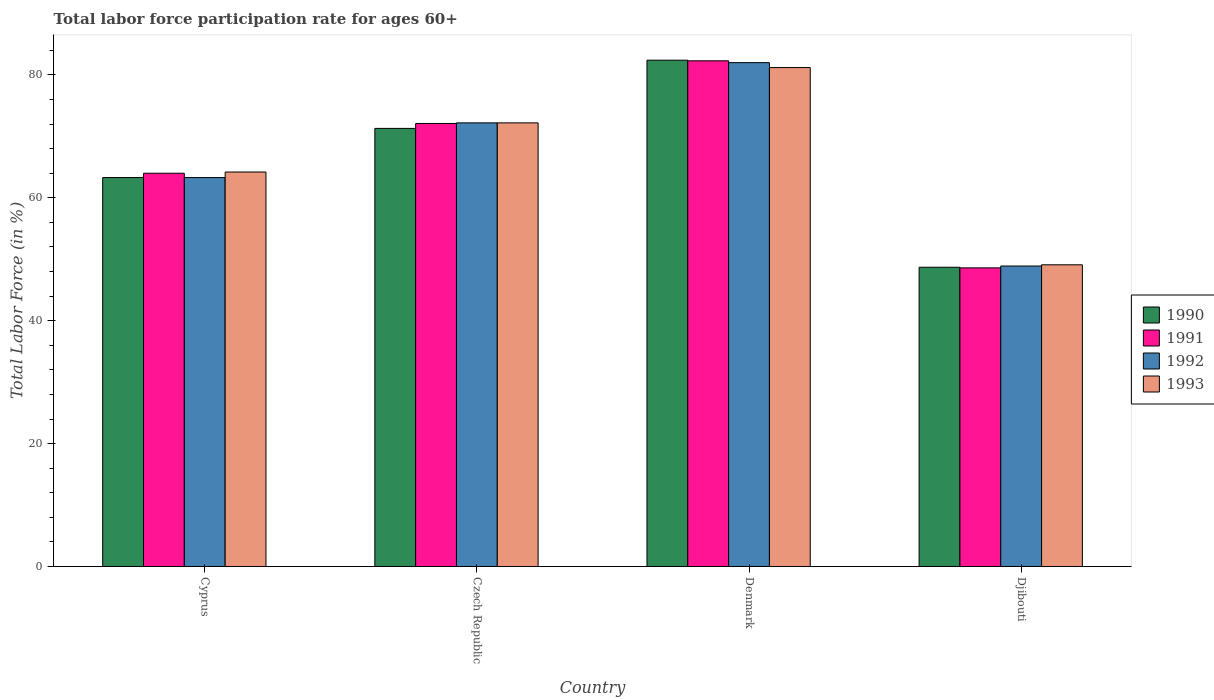How many different coloured bars are there?
Your answer should be very brief. 4. How many groups of bars are there?
Offer a very short reply. 4. How many bars are there on the 1st tick from the left?
Your answer should be very brief. 4. How many bars are there on the 3rd tick from the right?
Make the answer very short. 4. What is the label of the 2nd group of bars from the left?
Offer a very short reply. Czech Republic. In how many cases, is the number of bars for a given country not equal to the number of legend labels?
Make the answer very short. 0. What is the labor force participation rate in 1992 in Djibouti?
Offer a terse response. 48.9. Across all countries, what is the maximum labor force participation rate in 1991?
Your response must be concise. 82.3. Across all countries, what is the minimum labor force participation rate in 1993?
Keep it short and to the point. 49.1. In which country was the labor force participation rate in 1991 minimum?
Offer a terse response. Djibouti. What is the total labor force participation rate in 1992 in the graph?
Provide a short and direct response. 266.4. What is the difference between the labor force participation rate in 1991 in Czech Republic and that in Djibouti?
Offer a terse response. 23.5. What is the difference between the labor force participation rate in 1990 in Djibouti and the labor force participation rate in 1993 in Denmark?
Make the answer very short. -32.5. What is the average labor force participation rate in 1990 per country?
Ensure brevity in your answer.  66.43. What is the difference between the labor force participation rate of/in 1990 and labor force participation rate of/in 1992 in Djibouti?
Make the answer very short. -0.2. In how many countries, is the labor force participation rate in 1993 greater than 12 %?
Your response must be concise. 4. What is the ratio of the labor force participation rate in 1990 in Denmark to that in Djibouti?
Keep it short and to the point. 1.69. Is the difference between the labor force participation rate in 1990 in Czech Republic and Denmark greater than the difference between the labor force participation rate in 1992 in Czech Republic and Denmark?
Make the answer very short. No. What is the difference between the highest and the second highest labor force participation rate in 1991?
Keep it short and to the point. -10.2. What is the difference between the highest and the lowest labor force participation rate in 1991?
Ensure brevity in your answer.  33.7. In how many countries, is the labor force participation rate in 1992 greater than the average labor force participation rate in 1992 taken over all countries?
Ensure brevity in your answer.  2. What does the 2nd bar from the right in Czech Republic represents?
Give a very brief answer. 1992. Is it the case that in every country, the sum of the labor force participation rate in 1990 and labor force participation rate in 1992 is greater than the labor force participation rate in 1993?
Offer a terse response. Yes. How many countries are there in the graph?
Provide a succinct answer. 4. What is the difference between two consecutive major ticks on the Y-axis?
Make the answer very short. 20. Does the graph contain any zero values?
Your answer should be compact. No. Does the graph contain grids?
Ensure brevity in your answer.  No. How are the legend labels stacked?
Keep it short and to the point. Vertical. What is the title of the graph?
Ensure brevity in your answer.  Total labor force participation rate for ages 60+. What is the Total Labor Force (in %) of 1990 in Cyprus?
Your answer should be compact. 63.3. What is the Total Labor Force (in %) of 1991 in Cyprus?
Your answer should be very brief. 64. What is the Total Labor Force (in %) of 1992 in Cyprus?
Offer a terse response. 63.3. What is the Total Labor Force (in %) in 1993 in Cyprus?
Provide a succinct answer. 64.2. What is the Total Labor Force (in %) of 1990 in Czech Republic?
Give a very brief answer. 71.3. What is the Total Labor Force (in %) in 1991 in Czech Republic?
Your answer should be compact. 72.1. What is the Total Labor Force (in %) of 1992 in Czech Republic?
Keep it short and to the point. 72.2. What is the Total Labor Force (in %) of 1993 in Czech Republic?
Provide a short and direct response. 72.2. What is the Total Labor Force (in %) in 1990 in Denmark?
Your answer should be compact. 82.4. What is the Total Labor Force (in %) of 1991 in Denmark?
Provide a succinct answer. 82.3. What is the Total Labor Force (in %) in 1992 in Denmark?
Give a very brief answer. 82. What is the Total Labor Force (in %) in 1993 in Denmark?
Offer a terse response. 81.2. What is the Total Labor Force (in %) in 1990 in Djibouti?
Offer a very short reply. 48.7. What is the Total Labor Force (in %) of 1991 in Djibouti?
Provide a succinct answer. 48.6. What is the Total Labor Force (in %) of 1992 in Djibouti?
Offer a terse response. 48.9. What is the Total Labor Force (in %) in 1993 in Djibouti?
Your answer should be very brief. 49.1. Across all countries, what is the maximum Total Labor Force (in %) in 1990?
Give a very brief answer. 82.4. Across all countries, what is the maximum Total Labor Force (in %) of 1991?
Provide a short and direct response. 82.3. Across all countries, what is the maximum Total Labor Force (in %) of 1993?
Your answer should be very brief. 81.2. Across all countries, what is the minimum Total Labor Force (in %) of 1990?
Keep it short and to the point. 48.7. Across all countries, what is the minimum Total Labor Force (in %) of 1991?
Your response must be concise. 48.6. Across all countries, what is the minimum Total Labor Force (in %) of 1992?
Offer a very short reply. 48.9. Across all countries, what is the minimum Total Labor Force (in %) in 1993?
Keep it short and to the point. 49.1. What is the total Total Labor Force (in %) in 1990 in the graph?
Offer a terse response. 265.7. What is the total Total Labor Force (in %) of 1991 in the graph?
Offer a terse response. 267. What is the total Total Labor Force (in %) of 1992 in the graph?
Offer a terse response. 266.4. What is the total Total Labor Force (in %) in 1993 in the graph?
Provide a succinct answer. 266.7. What is the difference between the Total Labor Force (in %) of 1992 in Cyprus and that in Czech Republic?
Offer a very short reply. -8.9. What is the difference between the Total Labor Force (in %) of 1993 in Cyprus and that in Czech Republic?
Ensure brevity in your answer.  -8. What is the difference between the Total Labor Force (in %) of 1990 in Cyprus and that in Denmark?
Ensure brevity in your answer.  -19.1. What is the difference between the Total Labor Force (in %) in 1991 in Cyprus and that in Denmark?
Your answer should be compact. -18.3. What is the difference between the Total Labor Force (in %) in 1992 in Cyprus and that in Denmark?
Ensure brevity in your answer.  -18.7. What is the difference between the Total Labor Force (in %) in 1993 in Cyprus and that in Denmark?
Offer a very short reply. -17. What is the difference between the Total Labor Force (in %) of 1992 in Cyprus and that in Djibouti?
Your answer should be very brief. 14.4. What is the difference between the Total Labor Force (in %) of 1993 in Cyprus and that in Djibouti?
Provide a succinct answer. 15.1. What is the difference between the Total Labor Force (in %) of 1990 in Czech Republic and that in Denmark?
Your answer should be compact. -11.1. What is the difference between the Total Labor Force (in %) of 1992 in Czech Republic and that in Denmark?
Your answer should be very brief. -9.8. What is the difference between the Total Labor Force (in %) of 1993 in Czech Republic and that in Denmark?
Give a very brief answer. -9. What is the difference between the Total Labor Force (in %) of 1990 in Czech Republic and that in Djibouti?
Provide a short and direct response. 22.6. What is the difference between the Total Labor Force (in %) of 1992 in Czech Republic and that in Djibouti?
Your answer should be very brief. 23.3. What is the difference between the Total Labor Force (in %) in 1993 in Czech Republic and that in Djibouti?
Your answer should be very brief. 23.1. What is the difference between the Total Labor Force (in %) of 1990 in Denmark and that in Djibouti?
Ensure brevity in your answer.  33.7. What is the difference between the Total Labor Force (in %) in 1991 in Denmark and that in Djibouti?
Offer a terse response. 33.7. What is the difference between the Total Labor Force (in %) in 1992 in Denmark and that in Djibouti?
Your answer should be very brief. 33.1. What is the difference between the Total Labor Force (in %) of 1993 in Denmark and that in Djibouti?
Make the answer very short. 32.1. What is the difference between the Total Labor Force (in %) in 1990 in Cyprus and the Total Labor Force (in %) in 1991 in Czech Republic?
Keep it short and to the point. -8.8. What is the difference between the Total Labor Force (in %) in 1991 in Cyprus and the Total Labor Force (in %) in 1992 in Czech Republic?
Your answer should be compact. -8.2. What is the difference between the Total Labor Force (in %) in 1992 in Cyprus and the Total Labor Force (in %) in 1993 in Czech Republic?
Make the answer very short. -8.9. What is the difference between the Total Labor Force (in %) of 1990 in Cyprus and the Total Labor Force (in %) of 1991 in Denmark?
Provide a succinct answer. -19. What is the difference between the Total Labor Force (in %) of 1990 in Cyprus and the Total Labor Force (in %) of 1992 in Denmark?
Provide a short and direct response. -18.7. What is the difference between the Total Labor Force (in %) in 1990 in Cyprus and the Total Labor Force (in %) in 1993 in Denmark?
Your answer should be compact. -17.9. What is the difference between the Total Labor Force (in %) in 1991 in Cyprus and the Total Labor Force (in %) in 1993 in Denmark?
Your response must be concise. -17.2. What is the difference between the Total Labor Force (in %) in 1992 in Cyprus and the Total Labor Force (in %) in 1993 in Denmark?
Your answer should be compact. -17.9. What is the difference between the Total Labor Force (in %) of 1990 in Cyprus and the Total Labor Force (in %) of 1991 in Djibouti?
Keep it short and to the point. 14.7. What is the difference between the Total Labor Force (in %) in 1991 in Cyprus and the Total Labor Force (in %) in 1992 in Djibouti?
Make the answer very short. 15.1. What is the difference between the Total Labor Force (in %) of 1990 in Czech Republic and the Total Labor Force (in %) of 1991 in Denmark?
Ensure brevity in your answer.  -11. What is the difference between the Total Labor Force (in %) of 1990 in Czech Republic and the Total Labor Force (in %) of 1993 in Denmark?
Provide a short and direct response. -9.9. What is the difference between the Total Labor Force (in %) of 1990 in Czech Republic and the Total Labor Force (in %) of 1991 in Djibouti?
Offer a terse response. 22.7. What is the difference between the Total Labor Force (in %) of 1990 in Czech Republic and the Total Labor Force (in %) of 1992 in Djibouti?
Make the answer very short. 22.4. What is the difference between the Total Labor Force (in %) in 1991 in Czech Republic and the Total Labor Force (in %) in 1992 in Djibouti?
Provide a short and direct response. 23.2. What is the difference between the Total Labor Force (in %) in 1992 in Czech Republic and the Total Labor Force (in %) in 1993 in Djibouti?
Make the answer very short. 23.1. What is the difference between the Total Labor Force (in %) in 1990 in Denmark and the Total Labor Force (in %) in 1991 in Djibouti?
Provide a succinct answer. 33.8. What is the difference between the Total Labor Force (in %) of 1990 in Denmark and the Total Labor Force (in %) of 1992 in Djibouti?
Provide a short and direct response. 33.5. What is the difference between the Total Labor Force (in %) of 1990 in Denmark and the Total Labor Force (in %) of 1993 in Djibouti?
Provide a succinct answer. 33.3. What is the difference between the Total Labor Force (in %) of 1991 in Denmark and the Total Labor Force (in %) of 1992 in Djibouti?
Provide a short and direct response. 33.4. What is the difference between the Total Labor Force (in %) of 1991 in Denmark and the Total Labor Force (in %) of 1993 in Djibouti?
Provide a short and direct response. 33.2. What is the difference between the Total Labor Force (in %) of 1992 in Denmark and the Total Labor Force (in %) of 1993 in Djibouti?
Your answer should be compact. 32.9. What is the average Total Labor Force (in %) in 1990 per country?
Ensure brevity in your answer.  66.42. What is the average Total Labor Force (in %) of 1991 per country?
Your answer should be very brief. 66.75. What is the average Total Labor Force (in %) in 1992 per country?
Ensure brevity in your answer.  66.6. What is the average Total Labor Force (in %) in 1993 per country?
Offer a very short reply. 66.67. What is the difference between the Total Labor Force (in %) in 1990 and Total Labor Force (in %) in 1991 in Cyprus?
Make the answer very short. -0.7. What is the difference between the Total Labor Force (in %) in 1990 and Total Labor Force (in %) in 1992 in Cyprus?
Provide a short and direct response. 0. What is the difference between the Total Labor Force (in %) in 1991 and Total Labor Force (in %) in 1992 in Cyprus?
Ensure brevity in your answer.  0.7. What is the difference between the Total Labor Force (in %) of 1990 and Total Labor Force (in %) of 1991 in Czech Republic?
Your response must be concise. -0.8. What is the difference between the Total Labor Force (in %) of 1991 and Total Labor Force (in %) of 1993 in Czech Republic?
Ensure brevity in your answer.  -0.1. What is the difference between the Total Labor Force (in %) in 1990 and Total Labor Force (in %) in 1992 in Denmark?
Keep it short and to the point. 0.4. What is the difference between the Total Labor Force (in %) in 1990 and Total Labor Force (in %) in 1993 in Denmark?
Give a very brief answer. 1.2. What is the difference between the Total Labor Force (in %) in 1991 and Total Labor Force (in %) in 1993 in Denmark?
Your response must be concise. 1.1. What is the difference between the Total Labor Force (in %) in 1992 and Total Labor Force (in %) in 1993 in Denmark?
Your response must be concise. 0.8. What is the difference between the Total Labor Force (in %) in 1990 and Total Labor Force (in %) in 1991 in Djibouti?
Make the answer very short. 0.1. What is the difference between the Total Labor Force (in %) in 1990 and Total Labor Force (in %) in 1992 in Djibouti?
Your answer should be very brief. -0.2. What is the difference between the Total Labor Force (in %) of 1990 and Total Labor Force (in %) of 1993 in Djibouti?
Offer a very short reply. -0.4. What is the difference between the Total Labor Force (in %) of 1991 and Total Labor Force (in %) of 1992 in Djibouti?
Your answer should be very brief. -0.3. What is the difference between the Total Labor Force (in %) of 1991 and Total Labor Force (in %) of 1993 in Djibouti?
Your response must be concise. -0.5. What is the difference between the Total Labor Force (in %) of 1992 and Total Labor Force (in %) of 1993 in Djibouti?
Offer a terse response. -0.2. What is the ratio of the Total Labor Force (in %) of 1990 in Cyprus to that in Czech Republic?
Your answer should be very brief. 0.89. What is the ratio of the Total Labor Force (in %) of 1991 in Cyprus to that in Czech Republic?
Provide a short and direct response. 0.89. What is the ratio of the Total Labor Force (in %) of 1992 in Cyprus to that in Czech Republic?
Keep it short and to the point. 0.88. What is the ratio of the Total Labor Force (in %) of 1993 in Cyprus to that in Czech Republic?
Give a very brief answer. 0.89. What is the ratio of the Total Labor Force (in %) in 1990 in Cyprus to that in Denmark?
Your answer should be very brief. 0.77. What is the ratio of the Total Labor Force (in %) of 1991 in Cyprus to that in Denmark?
Your answer should be very brief. 0.78. What is the ratio of the Total Labor Force (in %) in 1992 in Cyprus to that in Denmark?
Give a very brief answer. 0.77. What is the ratio of the Total Labor Force (in %) of 1993 in Cyprus to that in Denmark?
Ensure brevity in your answer.  0.79. What is the ratio of the Total Labor Force (in %) in 1990 in Cyprus to that in Djibouti?
Keep it short and to the point. 1.3. What is the ratio of the Total Labor Force (in %) in 1991 in Cyprus to that in Djibouti?
Offer a very short reply. 1.32. What is the ratio of the Total Labor Force (in %) of 1992 in Cyprus to that in Djibouti?
Provide a succinct answer. 1.29. What is the ratio of the Total Labor Force (in %) in 1993 in Cyprus to that in Djibouti?
Your response must be concise. 1.31. What is the ratio of the Total Labor Force (in %) of 1990 in Czech Republic to that in Denmark?
Keep it short and to the point. 0.87. What is the ratio of the Total Labor Force (in %) of 1991 in Czech Republic to that in Denmark?
Provide a succinct answer. 0.88. What is the ratio of the Total Labor Force (in %) of 1992 in Czech Republic to that in Denmark?
Provide a succinct answer. 0.88. What is the ratio of the Total Labor Force (in %) in 1993 in Czech Republic to that in Denmark?
Offer a very short reply. 0.89. What is the ratio of the Total Labor Force (in %) in 1990 in Czech Republic to that in Djibouti?
Offer a terse response. 1.46. What is the ratio of the Total Labor Force (in %) of 1991 in Czech Republic to that in Djibouti?
Offer a terse response. 1.48. What is the ratio of the Total Labor Force (in %) of 1992 in Czech Republic to that in Djibouti?
Provide a short and direct response. 1.48. What is the ratio of the Total Labor Force (in %) in 1993 in Czech Republic to that in Djibouti?
Your answer should be very brief. 1.47. What is the ratio of the Total Labor Force (in %) in 1990 in Denmark to that in Djibouti?
Provide a succinct answer. 1.69. What is the ratio of the Total Labor Force (in %) in 1991 in Denmark to that in Djibouti?
Your answer should be compact. 1.69. What is the ratio of the Total Labor Force (in %) in 1992 in Denmark to that in Djibouti?
Offer a very short reply. 1.68. What is the ratio of the Total Labor Force (in %) in 1993 in Denmark to that in Djibouti?
Your answer should be very brief. 1.65. What is the difference between the highest and the second highest Total Labor Force (in %) of 1990?
Provide a succinct answer. 11.1. What is the difference between the highest and the second highest Total Labor Force (in %) in 1991?
Offer a very short reply. 10.2. What is the difference between the highest and the second highest Total Labor Force (in %) of 1992?
Your answer should be compact. 9.8. What is the difference between the highest and the second highest Total Labor Force (in %) in 1993?
Keep it short and to the point. 9. What is the difference between the highest and the lowest Total Labor Force (in %) of 1990?
Your answer should be very brief. 33.7. What is the difference between the highest and the lowest Total Labor Force (in %) of 1991?
Ensure brevity in your answer.  33.7. What is the difference between the highest and the lowest Total Labor Force (in %) of 1992?
Provide a short and direct response. 33.1. What is the difference between the highest and the lowest Total Labor Force (in %) of 1993?
Keep it short and to the point. 32.1. 